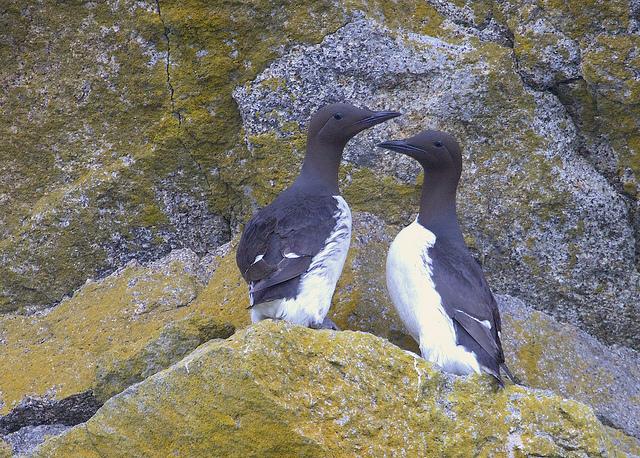How many birds are there?
Concise answer only. 2. Are the birds facing each other?
Concise answer only. Yes. What type of animals are these?
Concise answer only. Birds. 